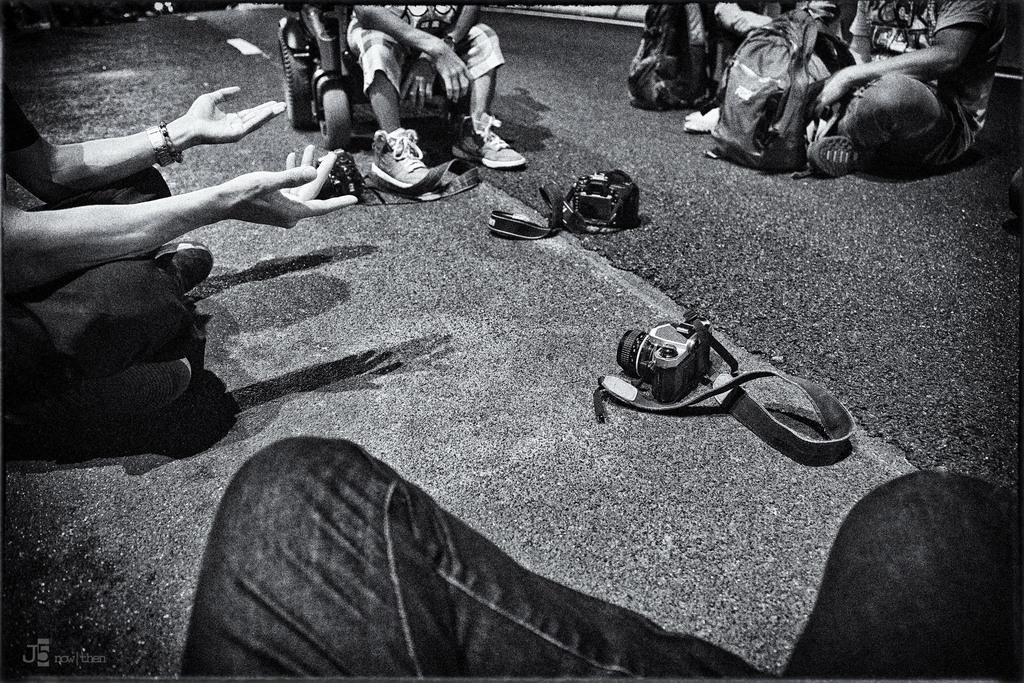What is the color scheme of the image? The image is black and white. What objects can be seen on the road in the image? There are cameras and bags on the road in the image. What are the people in the image doing? There are people sitting on the road in the image. Can you describe the person in the vehicle at the top of the image? There is a person in a vehicle at the top of the image. What type of juice is being served to the people sitting on the road in the image? There is no juice present in the image; the people are sitting on the road without any food or drink. 